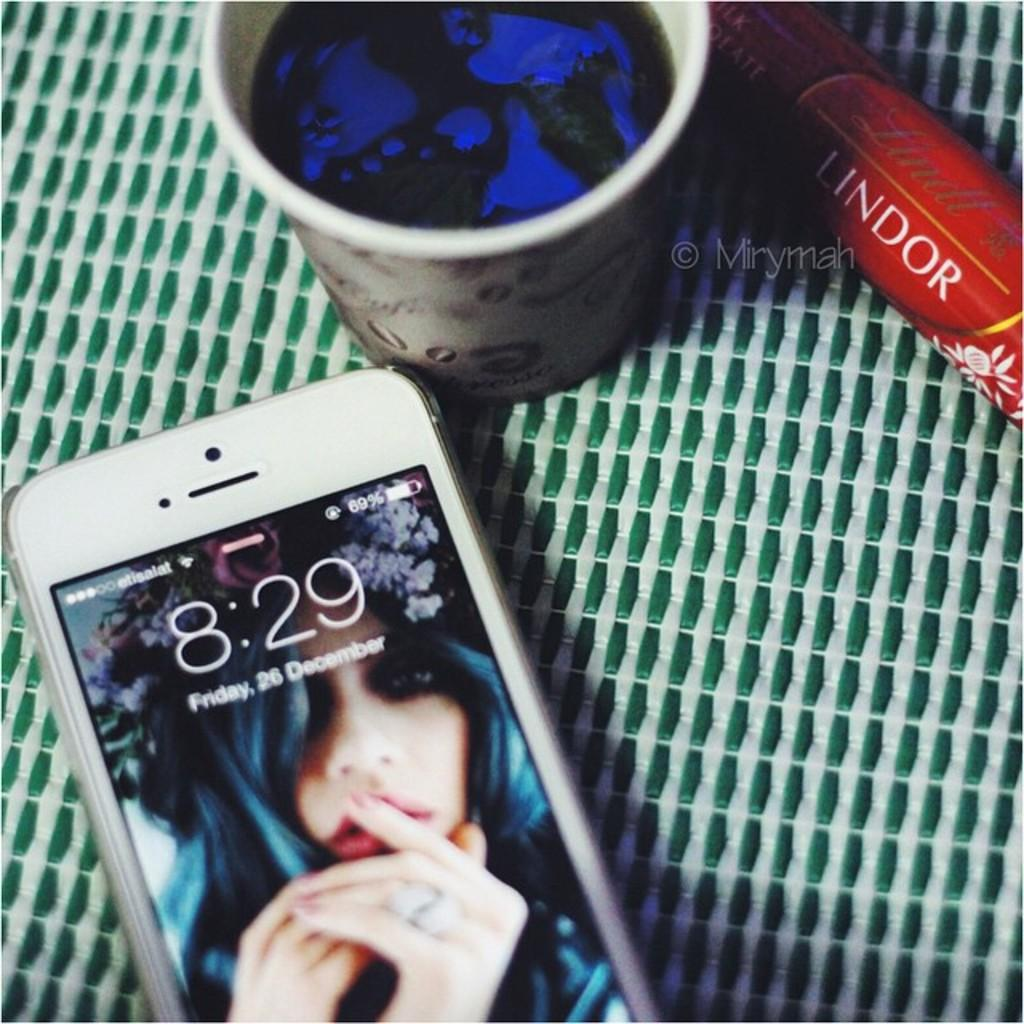What can be seen in the image that displays information or media? There is a mobile in the image that has a screen. What is located beside the mobile in the image? There is a glass beside the mobile. What is the color of the liquid in the glass? The liquid in the glass is blue. What object in the image has a red color? There is an object in the image with a red color. What type of friction can be observed between the mobile and the table in the image? There is no friction mentioned or observable between the mobile and the table in the image. 